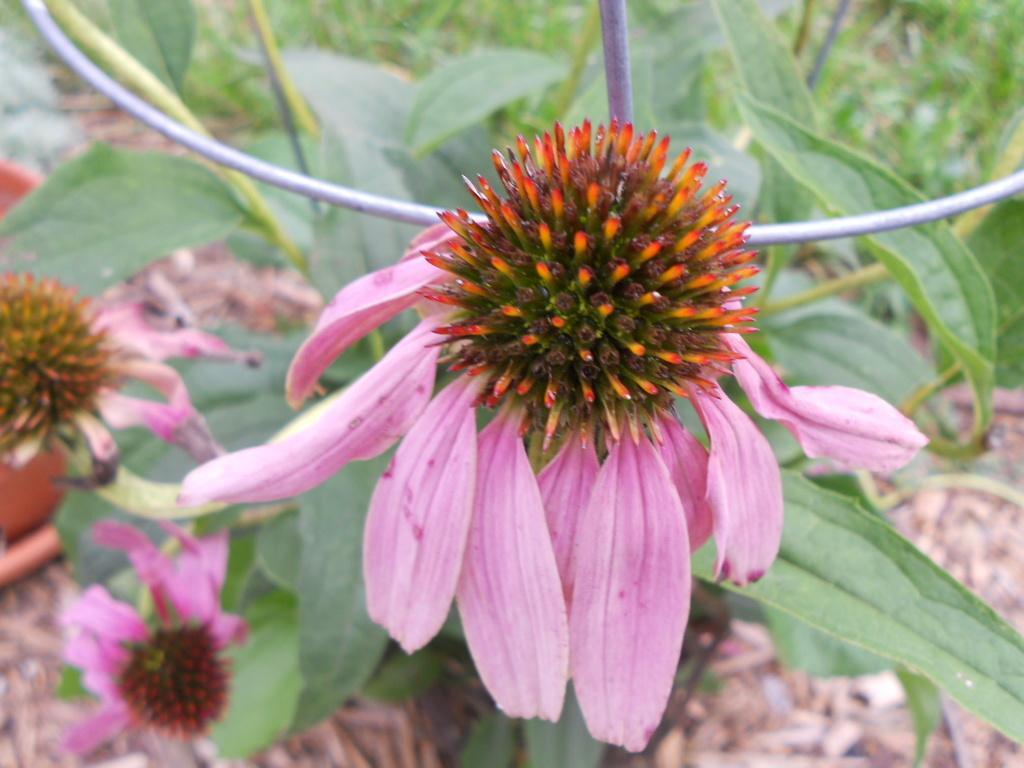Could you give a brief overview of what you see in this image? In this picture we can see some flowers to the plants. 